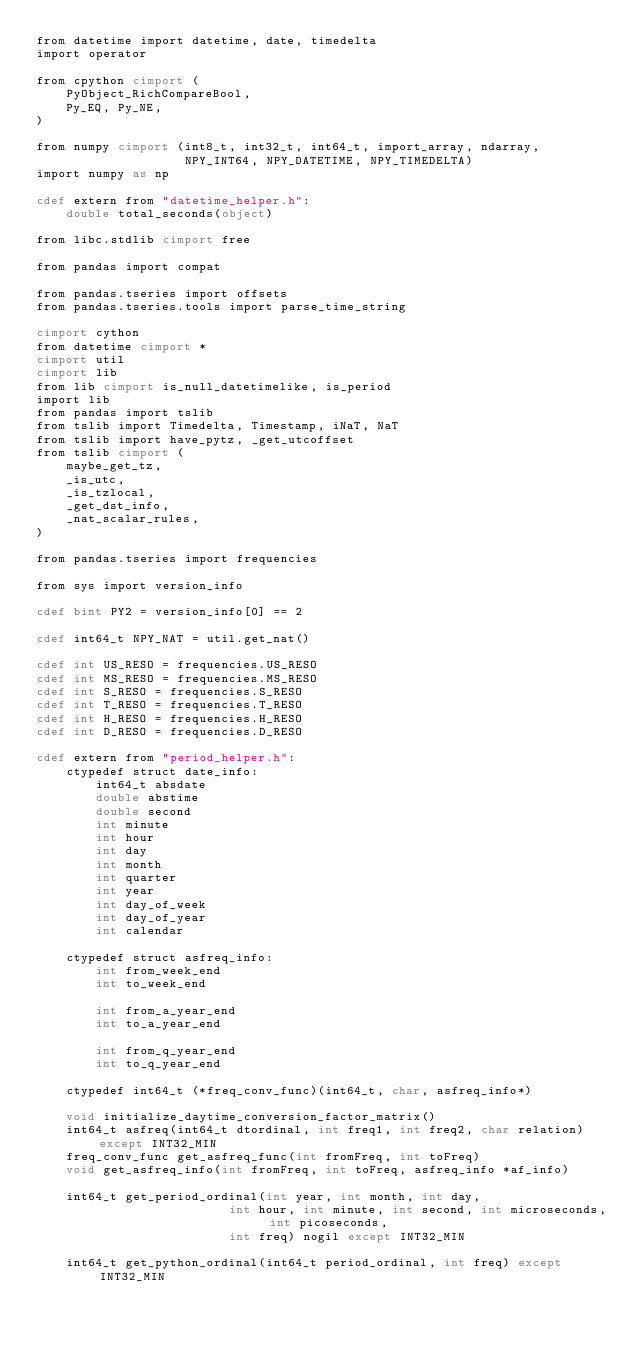<code> <loc_0><loc_0><loc_500><loc_500><_Cython_>from datetime import datetime, date, timedelta
import operator

from cpython cimport (
    PyObject_RichCompareBool,
    Py_EQ, Py_NE,
)

from numpy cimport (int8_t, int32_t, int64_t, import_array, ndarray,
                    NPY_INT64, NPY_DATETIME, NPY_TIMEDELTA)
import numpy as np

cdef extern from "datetime_helper.h":
    double total_seconds(object)

from libc.stdlib cimport free

from pandas import compat

from pandas.tseries import offsets
from pandas.tseries.tools import parse_time_string

cimport cython
from datetime cimport *
cimport util
cimport lib
from lib cimport is_null_datetimelike, is_period
import lib
from pandas import tslib
from tslib import Timedelta, Timestamp, iNaT, NaT
from tslib import have_pytz, _get_utcoffset
from tslib cimport (
    maybe_get_tz,
    _is_utc,
    _is_tzlocal,
    _get_dst_info,
    _nat_scalar_rules,
)

from pandas.tseries import frequencies

from sys import version_info

cdef bint PY2 = version_info[0] == 2

cdef int64_t NPY_NAT = util.get_nat()

cdef int US_RESO = frequencies.US_RESO
cdef int MS_RESO = frequencies.MS_RESO
cdef int S_RESO = frequencies.S_RESO
cdef int T_RESO = frequencies.T_RESO
cdef int H_RESO = frequencies.H_RESO
cdef int D_RESO = frequencies.D_RESO

cdef extern from "period_helper.h":
    ctypedef struct date_info:
        int64_t absdate
        double abstime
        double second
        int minute
        int hour
        int day
        int month
        int quarter
        int year
        int day_of_week
        int day_of_year
        int calendar

    ctypedef struct asfreq_info:
        int from_week_end
        int to_week_end

        int from_a_year_end
        int to_a_year_end

        int from_q_year_end
        int to_q_year_end

    ctypedef int64_t (*freq_conv_func)(int64_t, char, asfreq_info*)

    void initialize_daytime_conversion_factor_matrix()
    int64_t asfreq(int64_t dtordinal, int freq1, int freq2, char relation) except INT32_MIN
    freq_conv_func get_asfreq_func(int fromFreq, int toFreq)
    void get_asfreq_info(int fromFreq, int toFreq, asfreq_info *af_info)

    int64_t get_period_ordinal(int year, int month, int day,
                          int hour, int minute, int second, int microseconds, int picoseconds,
                          int freq) nogil except INT32_MIN

    int64_t get_python_ordinal(int64_t period_ordinal, int freq) except INT32_MIN
</code> 